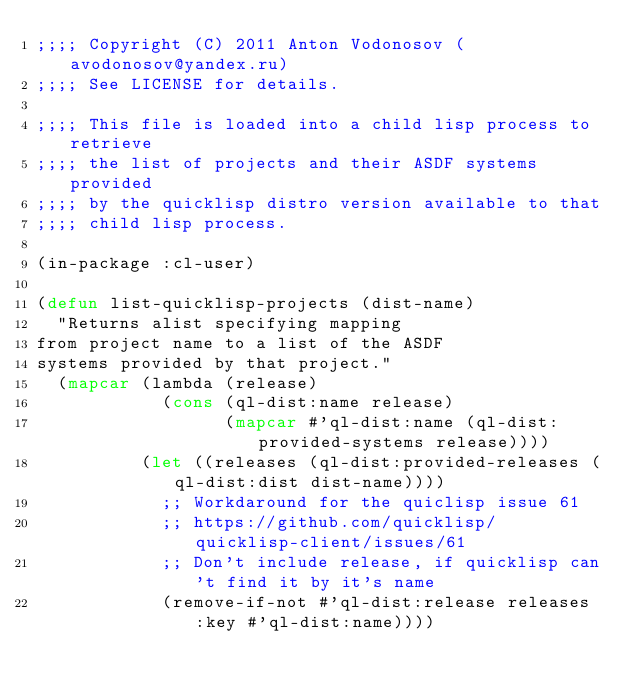<code> <loc_0><loc_0><loc_500><loc_500><_Lisp_>;;;; Copyright (C) 2011 Anton Vodonosov (avodonosov@yandex.ru)
;;;; See LICENSE for details.

;;;; This file is loaded into a child lisp process to retrieve
;;;; the list of projects and their ASDF systems provided
;;;; by the quicklisp distro version available to that
;;;; child lisp process.

(in-package :cl-user)

(defun list-quicklisp-projects (dist-name)
  "Returns alist specifying mapping
from project name to a list of the ASDF
systems provided by that project."
  (mapcar (lambda (release)
            (cons (ql-dist:name release)
                  (mapcar #'ql-dist:name (ql-dist:provided-systems release))))
          (let ((releases (ql-dist:provided-releases (ql-dist:dist dist-name))))
            ;; Workdaround for the quiclisp issue 61
            ;; https://github.com/quicklisp/quicklisp-client/issues/61
            ;; Don't include release, if quicklisp can't find it by it's name
            (remove-if-not #'ql-dist:release releases :key #'ql-dist:name))))
</code> 